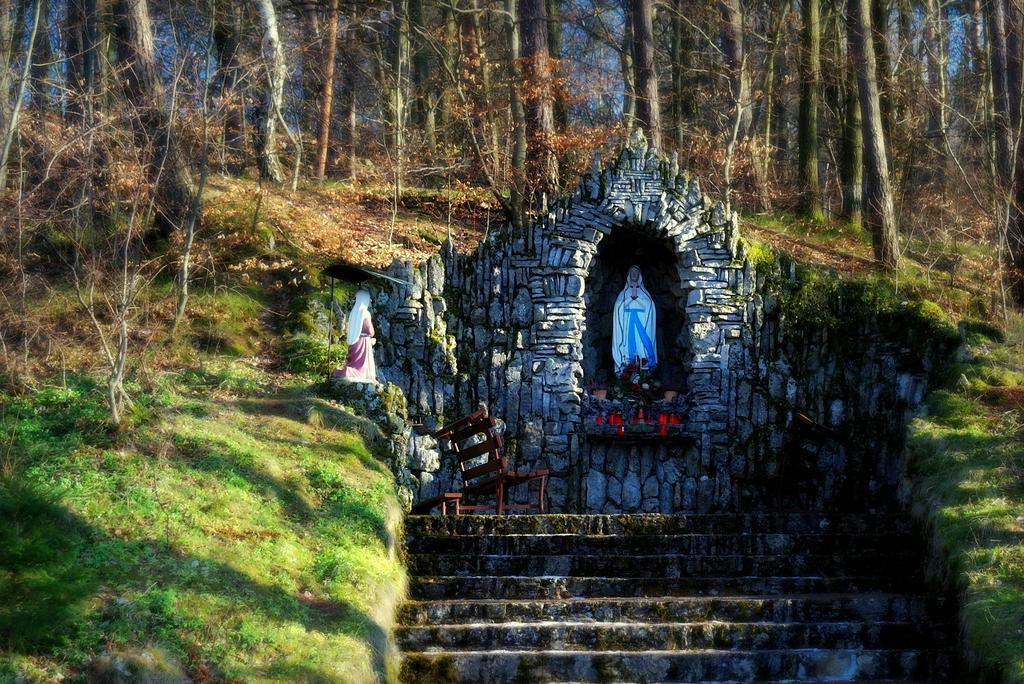In one or two sentences, can you explain what this image depicts? Here in this picture in the middle we can see statues present over a place and in the front we can see steps present and beside that on the ground we can see grass present and we can also see plants and trees present. 